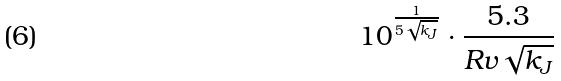Convert formula to latex. <formula><loc_0><loc_0><loc_500><loc_500>1 0 ^ { \frac { 1 } { 5 \sqrt { k _ { J } } } } \cdot \frac { 5 . 3 } { R v \sqrt { k _ { J } } }</formula> 